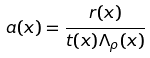Convert formula to latex. <formula><loc_0><loc_0><loc_500><loc_500>a ( x ) = \frac { r ( x ) } { t ( x ) \Lambda _ { \rho } ( x ) }</formula> 